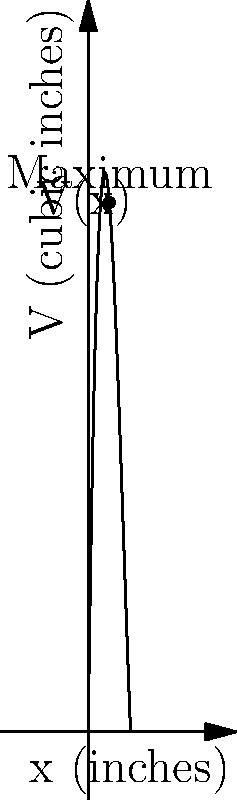A rectangular box with no top is to be constructed from a 30-inch by 15-inch piece of cardboard. The base of the box will be formed by folding up the sides, creating a box with length $l$, width $w$, and height $x$. If we want to maximize the volume of the box, what should the height $x$ be? Use the given graph to support your answer. Let's approach this step-by-step:

1) First, we need to express the volume $V$ in terms of $x$:
   $V = lwx$
   $l = 30 - 2x$ (because we fold up $x$ inches on each side)
   $w = 15 - 2x$ (same reason)
   So, $V = (30-2x)(15-2x)x = (450-90x+4x^2)x = 450x - 90x^2 + 4x^3$

2) The volume function is graphed in the figure. We can see that it reaches a maximum at a certain point.

3) To find the exact maximum, we would normally take the derivative of $V$ with respect to $x$, set it to zero, and solve. However, we can use the graph to estimate the solution.

4) From the graph, we can see that the maximum occurs at approximately $x = 2.5$ inches.

5) This makes sense practically: if $x$ is too small, the box will be very shallow; if $x$ is too large, the base will become too small. The optimal height balances these factors.

6) We can verify this by calculating a few values:
   At $x = 2$: $V = 2(26)(11) = 572$ cubic inches
   At $x = 2.5$: $V = 2.5(25)(10) = 625$ cubic inches
   At $x = 3$: $V = 3(24)(9) = 648$ cubic inches

7) While 3 inches gives a slightly larger volume in this rough calculation, the graph clearly shows the maximum is closer to 2.5 inches.
Answer: $2.5$ inches 